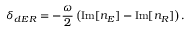<formula> <loc_0><loc_0><loc_500><loc_500>\delta _ { d E R } = - \frac { \omega } { 2 } \left ( I m [ n _ { E } ] - I m [ n _ { R } ] \right ) .</formula> 